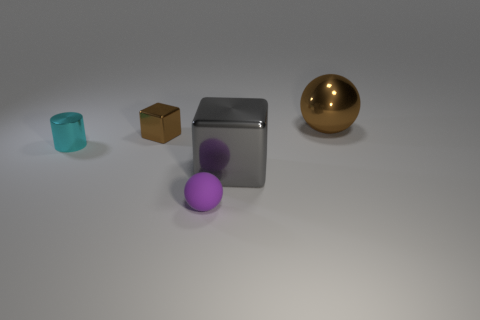What size is the sphere that is the same color as the tiny block?
Your response must be concise. Large. What is the size of the ball that is behind the brown object to the left of the large gray object?
Give a very brief answer. Large. There is a matte object that is the same shape as the large brown metal object; what is its color?
Give a very brief answer. Purple. What number of small spheres have the same color as the large sphere?
Ensure brevity in your answer.  0. The gray thing is what size?
Your answer should be compact. Large. Does the matte object have the same size as the metallic cylinder?
Offer a very short reply. Yes. There is a object that is both on the right side of the small metal block and to the left of the large gray shiny thing; what is its color?
Your answer should be very brief. Purple. How many other objects are the same material as the cyan thing?
Ensure brevity in your answer.  3. What number of small shiny spheres are there?
Give a very brief answer. 0. There is a gray metal block; is its size the same as the shiny block that is left of the tiny rubber object?
Your response must be concise. No. 